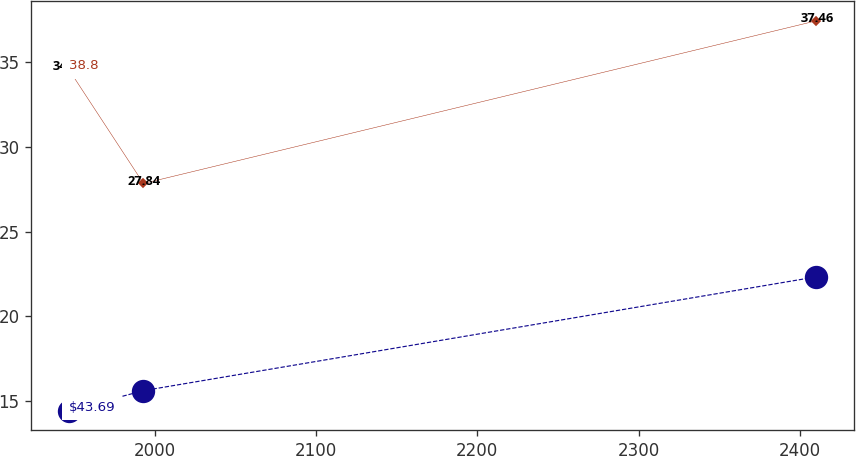Convert chart to OTSL. <chart><loc_0><loc_0><loc_500><loc_500><line_chart><ecel><fcel>$43.69<fcel>38.8<nl><fcel>1946.84<fcel>14.41<fcel>34.59<nl><fcel>1993.16<fcel>15.59<fcel>27.84<nl><fcel>2410.05<fcel>22.32<fcel>37.46<nl></chart> 